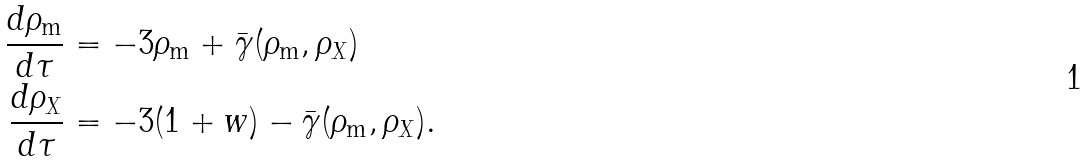<formula> <loc_0><loc_0><loc_500><loc_500>\frac { d \rho _ { \text {m} } } { d \tau } & = - 3 \rho _ { \text {m} } + \bar { \gamma } ( \rho _ { \text {m} } , \rho _ { X } ) \\ \frac { d \rho _ { X } } { d \tau } & = - 3 ( 1 + w ) - \bar { \gamma } ( \rho _ { \text {m} } , \rho _ { X } ) .</formula> 